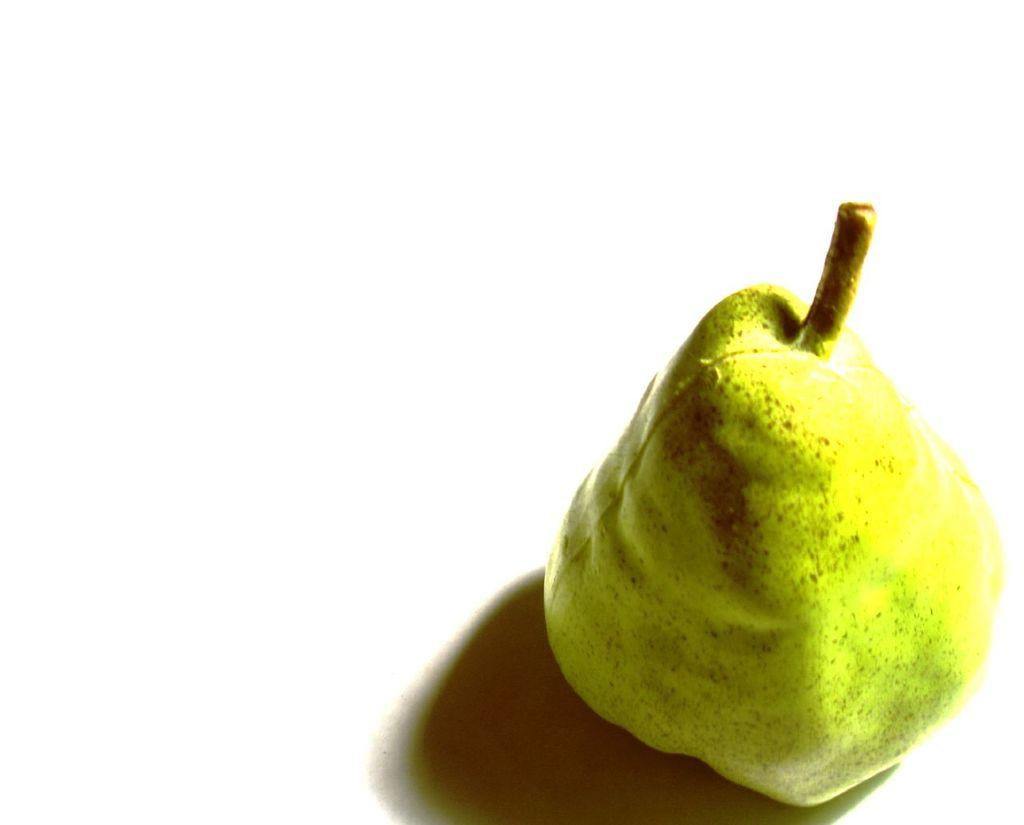What type of fruit is in the image? There is a pear in the image. What is the color of the surface on which the pear is placed? The pear is placed on a white surface. How many chairs are visible in the image? There are no chairs visible in the image; it only features a pear on a white surface. What type of food is being prepared in the image? There is no food preparation visible in the image; it only features a pear on a white surface. 